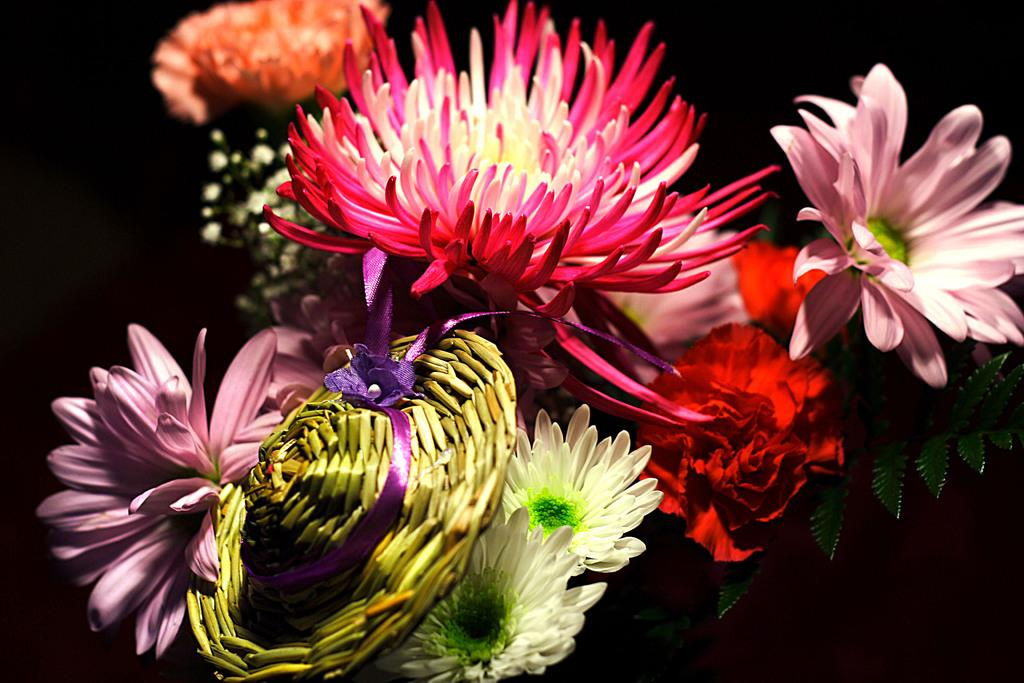What is the overall color scheme of the image? The background of the image is dark. What can be seen in the foreground of the image? There is a bouquet with beautiful flowers in the image. What type of object is also present in the image? There is a toy hat in the image. Can you see any fairies flying around the bouquet in the image? There are no fairies present in the image; it only features a bouquet of flowers and a toy hat. What type of lock can be seen securing the toy hat in the image? There is no lock present in the image; the toy hat is not secured in any way. 